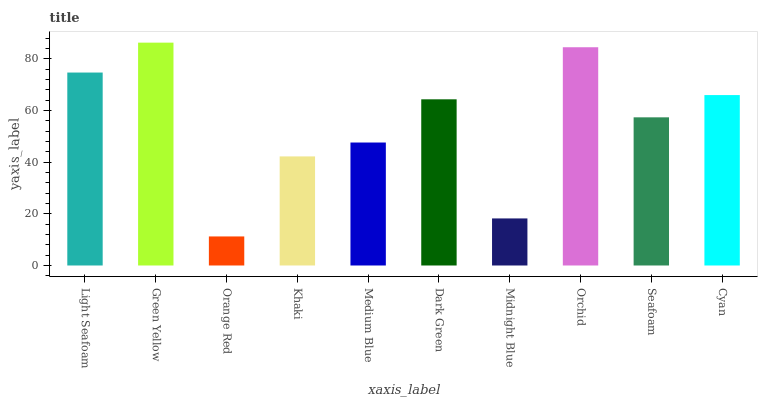Is Orange Red the minimum?
Answer yes or no. Yes. Is Green Yellow the maximum?
Answer yes or no. Yes. Is Green Yellow the minimum?
Answer yes or no. No. Is Orange Red the maximum?
Answer yes or no. No. Is Green Yellow greater than Orange Red?
Answer yes or no. Yes. Is Orange Red less than Green Yellow?
Answer yes or no. Yes. Is Orange Red greater than Green Yellow?
Answer yes or no. No. Is Green Yellow less than Orange Red?
Answer yes or no. No. Is Dark Green the high median?
Answer yes or no. Yes. Is Seafoam the low median?
Answer yes or no. Yes. Is Green Yellow the high median?
Answer yes or no. No. Is Medium Blue the low median?
Answer yes or no. No. 